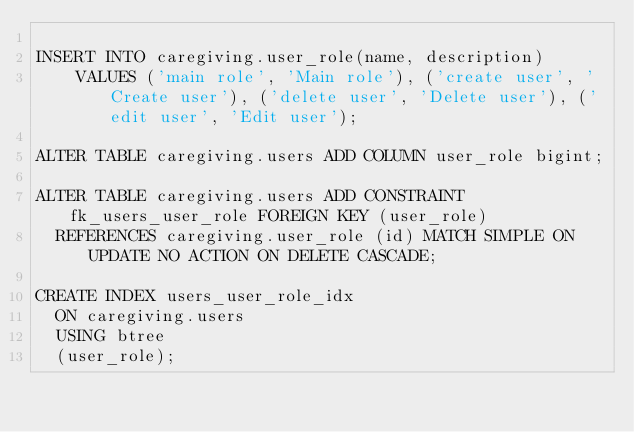Convert code to text. <code><loc_0><loc_0><loc_500><loc_500><_SQL_>
INSERT INTO caregiving.user_role(name, description)
    VALUES ('main role', 'Main role'), ('create user', 'Create user'), ('delete user', 'Delete user'), ('edit user', 'Edit user');

ALTER TABLE caregiving.users ADD COLUMN user_role bigint;

ALTER TABLE caregiving.users ADD CONSTRAINT fk_users_user_role FOREIGN KEY (user_role)
  REFERENCES caregiving.user_role (id) MATCH SIMPLE ON UPDATE NO ACTION ON DELETE CASCADE;

CREATE INDEX users_user_role_idx
  ON caregiving.users
  USING btree
  (user_role);

</code> 